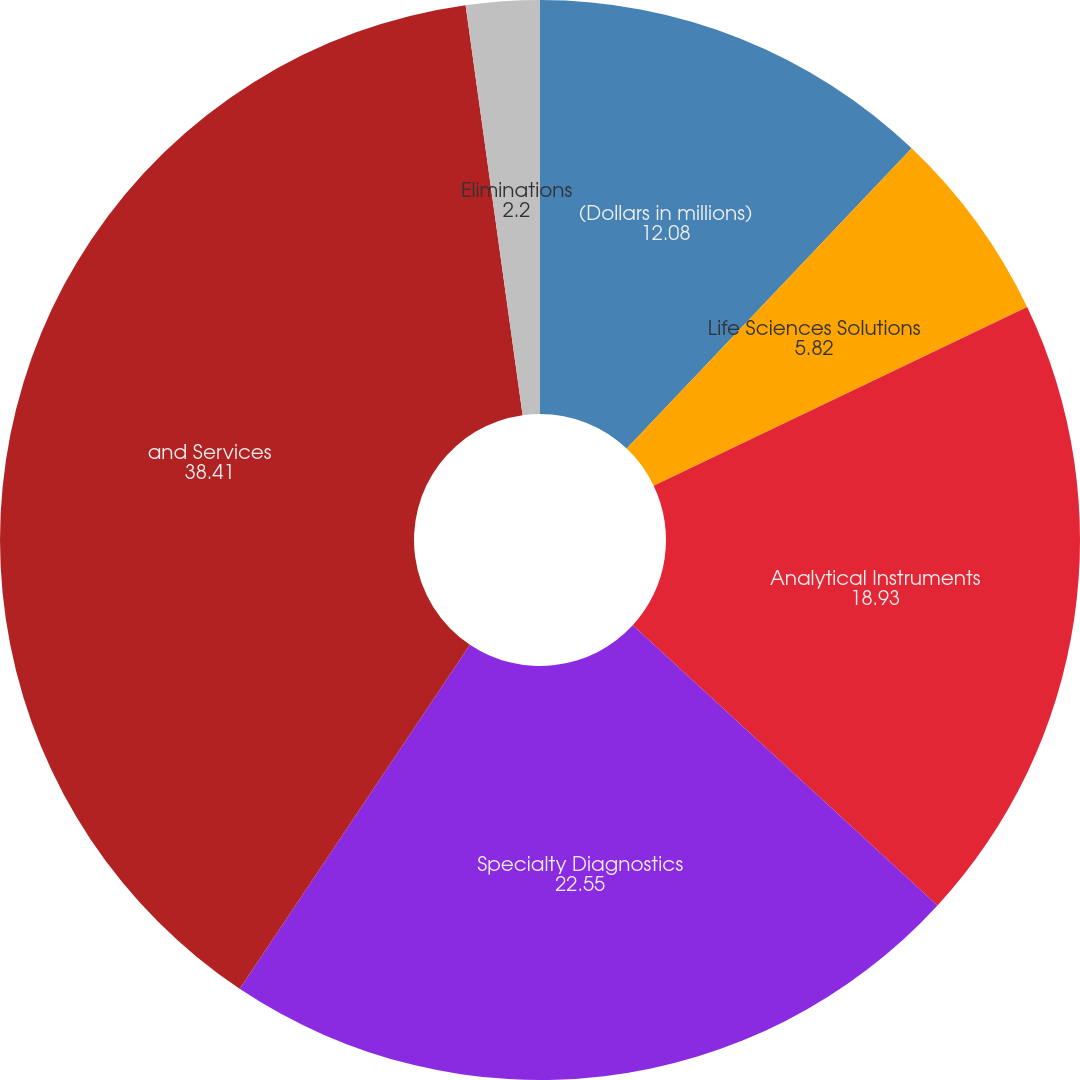Convert chart. <chart><loc_0><loc_0><loc_500><loc_500><pie_chart><fcel>(Dollars in millions)<fcel>Life Sciences Solutions<fcel>Analytical Instruments<fcel>Specialty Diagnostics<fcel>and Services<fcel>Eliminations<nl><fcel>12.08%<fcel>5.82%<fcel>18.93%<fcel>22.55%<fcel>38.41%<fcel>2.2%<nl></chart> 